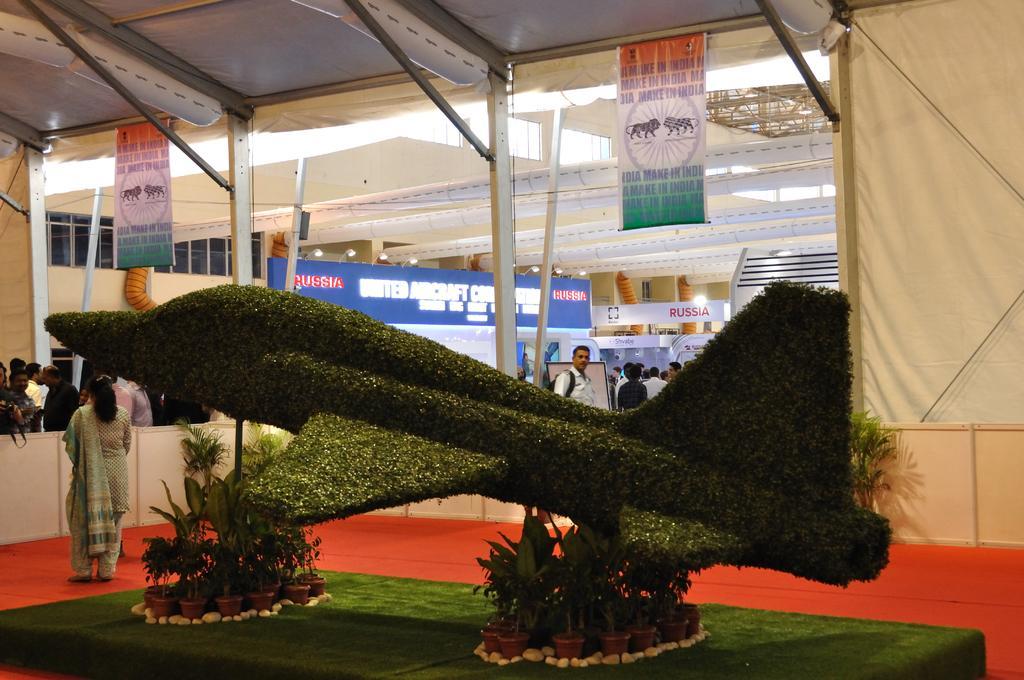Describe this image in one or two sentences. In the center of the image, we can see a grass statue and there are some pots. In the background, we can see people, building, hoardings and some posters. 